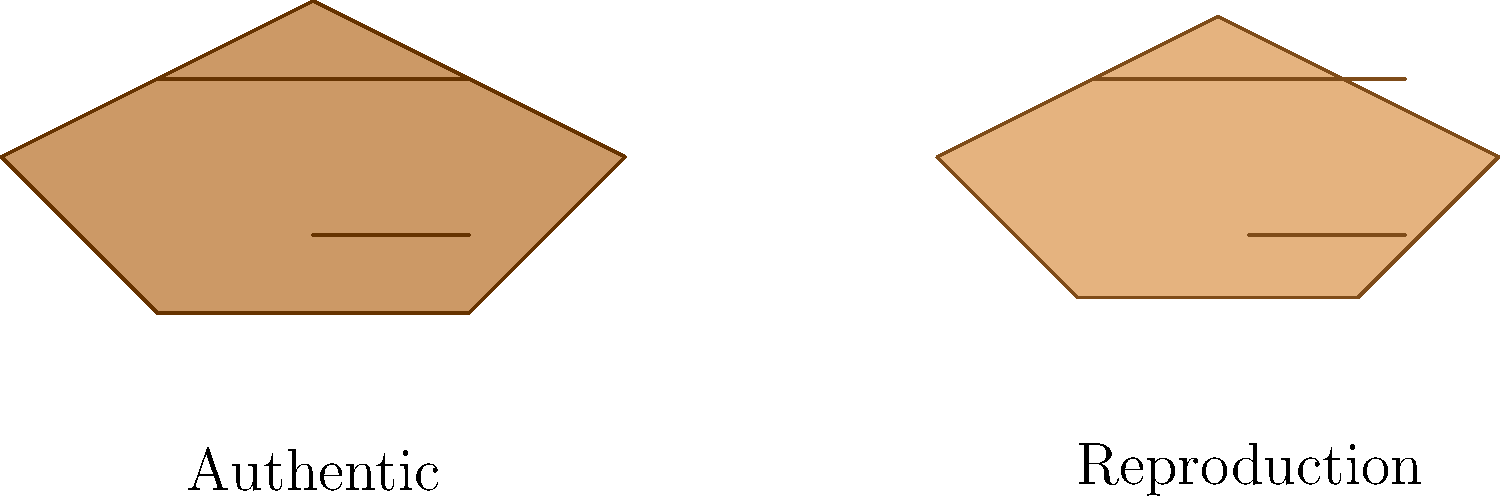Based on the side-by-side comparison of these Art Nouveau jewelry pieces, which characteristic most clearly distinguishes the authentic piece from the reproduction? To distinguish between authentic and reproduction Art Nouveau jewelry pieces, we need to analyze several key factors:

1. Quality of craftsmanship: Authentic pieces typically show superior craftsmanship with more intricate and precise details.

2. Materials: Authentic Art Nouveau jewelry often uses higher quality materials, which can be observed in the color and texture of the piece.

3. Patina: Authentic pieces develop a natural patina over time, giving them a distinct aged appearance.

4. Design intricacy: Art Nouveau is known for its organic, flowing lines and nature-inspired motifs. Authentic pieces often have more complex and fluid designs.

5. Scale and proportions: Reproductions may have slightly different proportions or be smaller in scale to reduce production costs.

In this comparison:

- The authentic piece (left) shows deeper, more defined lines and details.
- The color of the authentic piece is richer and more nuanced, suggesting higher quality materials.
- The authentic piece has a more complex overall design with additional detailing.
- The reproduction (right) appears slightly smaller and lacks the same level of intricacy in its design elements.

The most distinguishing characteristic in this case is the quality and intricacy of the detailing, which is notably superior in the authentic piece.
Answer: Quality and intricacy of detailing 